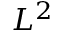<formula> <loc_0><loc_0><loc_500><loc_500>L ^ { 2 }</formula> 